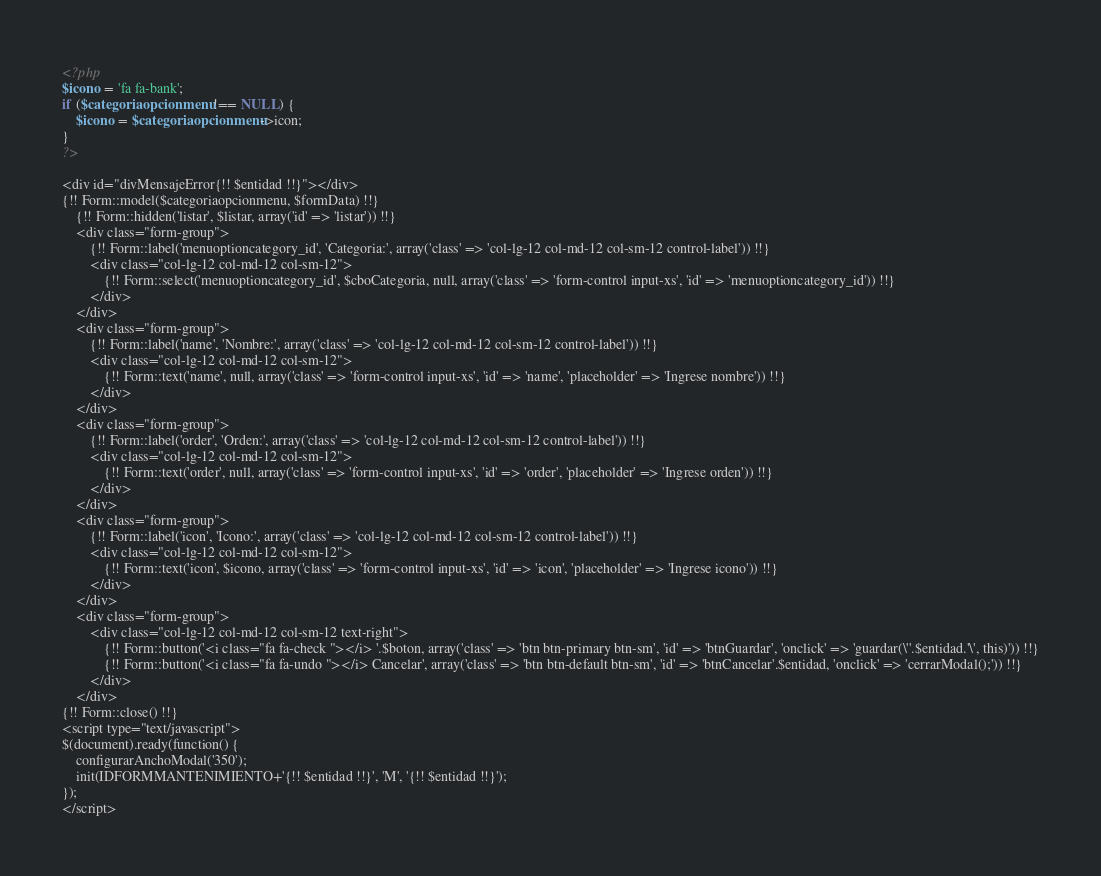<code> <loc_0><loc_0><loc_500><loc_500><_PHP_><?php 
$icono = 'fa fa-bank';
if ($categoriaopcionmenu !== NULL) {
	$icono = $categoriaopcionmenu->icon;
}
?>

<div id="divMensajeError{!! $entidad !!}"></div>
{!! Form::model($categoriaopcionmenu, $formData) !!}	
	{!! Form::hidden('listar', $listar, array('id' => 'listar')) !!}
	<div class="form-group">
		{!! Form::label('menuoptioncategory_id', 'Categoria:', array('class' => 'col-lg-12 col-md-12 col-sm-12 control-label')) !!}
		<div class="col-lg-12 col-md-12 col-sm-12">
			{!! Form::select('menuoptioncategory_id', $cboCategoria, null, array('class' => 'form-control input-xs', 'id' => 'menuoptioncategory_id')) !!}
		</div>
	</div>
	<div class="form-group">
		{!! Form::label('name', 'Nombre:', array('class' => 'col-lg-12 col-md-12 col-sm-12 control-label')) !!}
		<div class="col-lg-12 col-md-12 col-sm-12">
			{!! Form::text('name', null, array('class' => 'form-control input-xs', 'id' => 'name', 'placeholder' => 'Ingrese nombre')) !!}
		</div>
	</div>
	<div class="form-group">
		{!! Form::label('order', 'Orden:', array('class' => 'col-lg-12 col-md-12 col-sm-12 control-label')) !!}
		<div class="col-lg-12 col-md-12 col-sm-12">
			{!! Form::text('order', null, array('class' => 'form-control input-xs', 'id' => 'order', 'placeholder' => 'Ingrese orden')) !!}
		</div>
	</div>
	<div class="form-group">
		{!! Form::label('icon', 'Icono:', array('class' => 'col-lg-12 col-md-12 col-sm-12 control-label')) !!}
		<div class="col-lg-12 col-md-12 col-sm-12">
			{!! Form::text('icon', $icono, array('class' => 'form-control input-xs', 'id' => 'icon', 'placeholder' => 'Ingrese icono')) !!}
		</div>
	</div>
	<div class="form-group">
		<div class="col-lg-12 col-md-12 col-sm-12 text-right">
			{!! Form::button('<i class="fa fa-check "></i> '.$boton, array('class' => 'btn btn-primary btn-sm', 'id' => 'btnGuardar', 'onclick' => 'guardar(\''.$entidad.'\', this)')) !!}
			{!! Form::button('<i class="fa fa-undo "></i> Cancelar', array('class' => 'btn btn-default btn-sm', 'id' => 'btnCancelar'.$entidad, 'onclick' => 'cerrarModal();')) !!}
		</div>
	</div>
{!! Form::close() !!}
<script type="text/javascript">
$(document).ready(function() {
	configurarAnchoModal('350');
	init(IDFORMMANTENIMIENTO+'{!! $entidad !!}', 'M', '{!! $entidad !!}');
}); 
</script></code> 